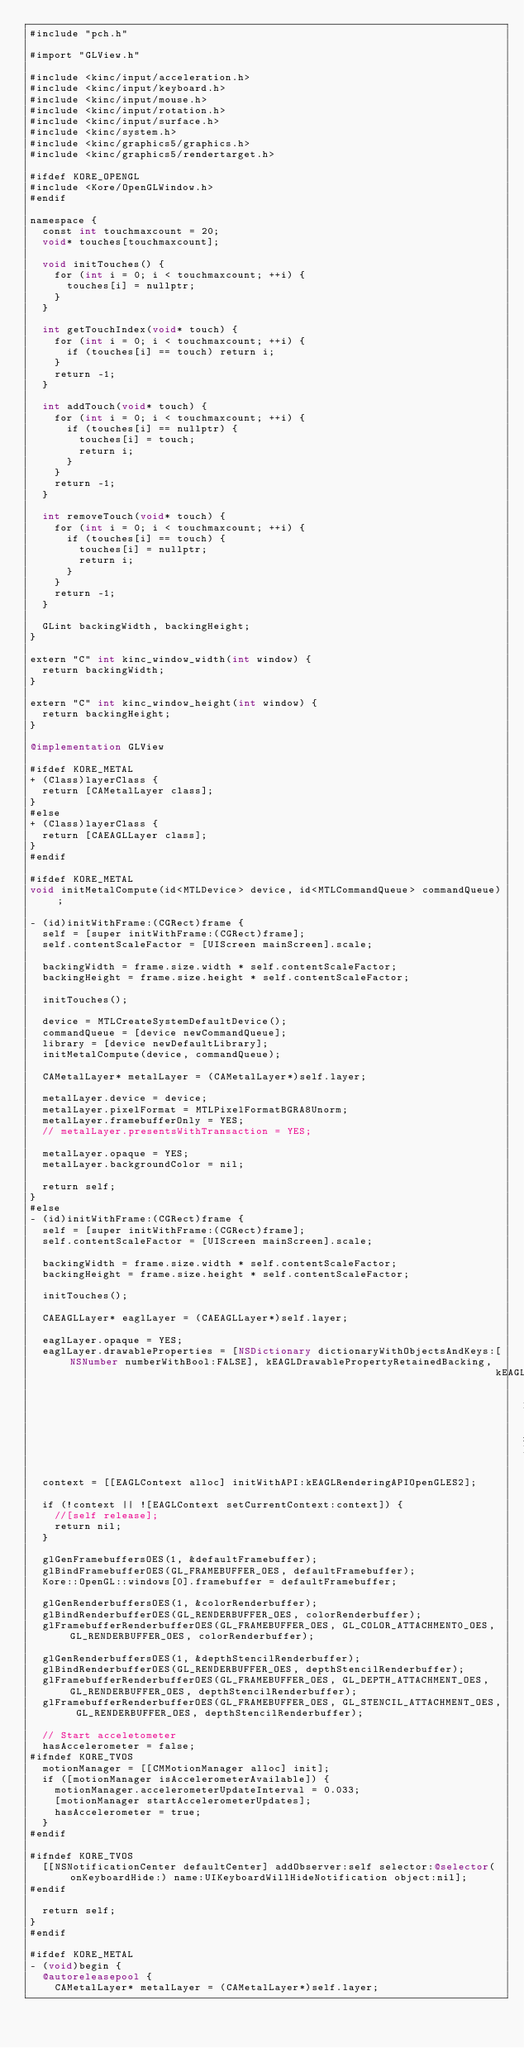Convert code to text. <code><loc_0><loc_0><loc_500><loc_500><_ObjectiveC_>#include "pch.h"

#import "GLView.h"

#include <kinc/input/acceleration.h>
#include <kinc/input/keyboard.h>
#include <kinc/input/mouse.h>
#include <kinc/input/rotation.h>
#include <kinc/input/surface.h>
#include <kinc/system.h>
#include <kinc/graphics5/graphics.h>
#include <kinc/graphics5/rendertarget.h>

#ifdef KORE_OPENGL
#include <Kore/OpenGLWindow.h>
#endif

namespace {
	const int touchmaxcount = 20;
	void* touches[touchmaxcount];

	void initTouches() {
		for (int i = 0; i < touchmaxcount; ++i) {
			touches[i] = nullptr;
		}
	}

	int getTouchIndex(void* touch) {
		for (int i = 0; i < touchmaxcount; ++i) {
			if (touches[i] == touch) return i;
		}
		return -1;
	}

	int addTouch(void* touch) {
		for (int i = 0; i < touchmaxcount; ++i) {
			if (touches[i] == nullptr) {
				touches[i] = touch;
				return i;
			}
		}
		return -1;
	}

	int removeTouch(void* touch) {
		for (int i = 0; i < touchmaxcount; ++i) {
			if (touches[i] == touch) {
				touches[i] = nullptr;
				return i;
			}
		}
		return -1;
	}

	GLint backingWidth, backingHeight;
}

extern "C" int kinc_window_width(int window) {
	return backingWidth;
}

extern "C" int kinc_window_height(int window) {
	return backingHeight;
}

@implementation GLView

#ifdef KORE_METAL
+ (Class)layerClass {
	return [CAMetalLayer class];
}
#else
+ (Class)layerClass {
	return [CAEAGLLayer class];
}
#endif

#ifdef KORE_METAL
void initMetalCompute(id<MTLDevice> device, id<MTLCommandQueue> commandQueue);

- (id)initWithFrame:(CGRect)frame {
	self = [super initWithFrame:(CGRect)frame];
	self.contentScaleFactor = [UIScreen mainScreen].scale;

	backingWidth = frame.size.width * self.contentScaleFactor;
	backingHeight = frame.size.height * self.contentScaleFactor;
	
	initTouches();

	device = MTLCreateSystemDefaultDevice();
	commandQueue = [device newCommandQueue];
	library = [device newDefaultLibrary];
	initMetalCompute(device, commandQueue);

	CAMetalLayer* metalLayer = (CAMetalLayer*)self.layer;

	metalLayer.device = device;
	metalLayer.pixelFormat = MTLPixelFormatBGRA8Unorm;
	metalLayer.framebufferOnly = YES;
	// metalLayer.presentsWithTransaction = YES;

	metalLayer.opaque = YES;
	metalLayer.backgroundColor = nil;

	return self;
}
#else
- (id)initWithFrame:(CGRect)frame {
	self = [super initWithFrame:(CGRect)frame];
	self.contentScaleFactor = [UIScreen mainScreen].scale;
	
	backingWidth = frame.size.width * self.contentScaleFactor;
	backingHeight = frame.size.height * self.contentScaleFactor;

	initTouches();

	CAEAGLLayer* eaglLayer = (CAEAGLLayer*)self.layer;

	eaglLayer.opaque = YES;
	eaglLayer.drawableProperties = [NSDictionary dictionaryWithObjectsAndKeys:[NSNumber numberWithBool:FALSE], kEAGLDrawablePropertyRetainedBacking,
	                                                                          kEAGLColorFormatRGBA8, kEAGLDrawablePropertyColorFormat, nil];

	context = [[EAGLContext alloc] initWithAPI:kEAGLRenderingAPIOpenGLES2];

	if (!context || ![EAGLContext setCurrentContext:context]) {
		//[self release];
		return nil;
	}

	glGenFramebuffersOES(1, &defaultFramebuffer);
	glBindFramebufferOES(GL_FRAMEBUFFER_OES, defaultFramebuffer);
	Kore::OpenGL::windows[0].framebuffer = defaultFramebuffer;
	
	glGenRenderbuffersOES(1, &colorRenderbuffer);
	glBindRenderbufferOES(GL_RENDERBUFFER_OES, colorRenderbuffer);
	glFramebufferRenderbufferOES(GL_FRAMEBUFFER_OES, GL_COLOR_ATTACHMENT0_OES, GL_RENDERBUFFER_OES, colorRenderbuffer);

	glGenRenderbuffersOES(1, &depthStencilRenderbuffer);
	glBindRenderbufferOES(GL_RENDERBUFFER_OES, depthStencilRenderbuffer);
	glFramebufferRenderbufferOES(GL_FRAMEBUFFER_OES, GL_DEPTH_ATTACHMENT_OES, GL_RENDERBUFFER_OES, depthStencilRenderbuffer);
	glFramebufferRenderbufferOES(GL_FRAMEBUFFER_OES, GL_STENCIL_ATTACHMENT_OES, GL_RENDERBUFFER_OES, depthStencilRenderbuffer);

	// Start acceletometer
	hasAccelerometer = false;
#ifndef KORE_TVOS
	motionManager = [[CMMotionManager alloc] init];
	if ([motionManager isAccelerometerAvailable]) {
		motionManager.accelerometerUpdateInterval = 0.033;
		[motionManager startAccelerometerUpdates];
		hasAccelerometer = true;
	}
#endif

#ifndef KORE_TVOS
	[[NSNotificationCenter defaultCenter] addObserver:self selector:@selector(onKeyboardHide:) name:UIKeyboardWillHideNotification object:nil];
#endif

	return self;
}
#endif

#ifdef KORE_METAL
- (void)begin {
	@autoreleasepool {
		CAMetalLayer* metalLayer = (CAMetalLayer*)self.layer;
</code> 